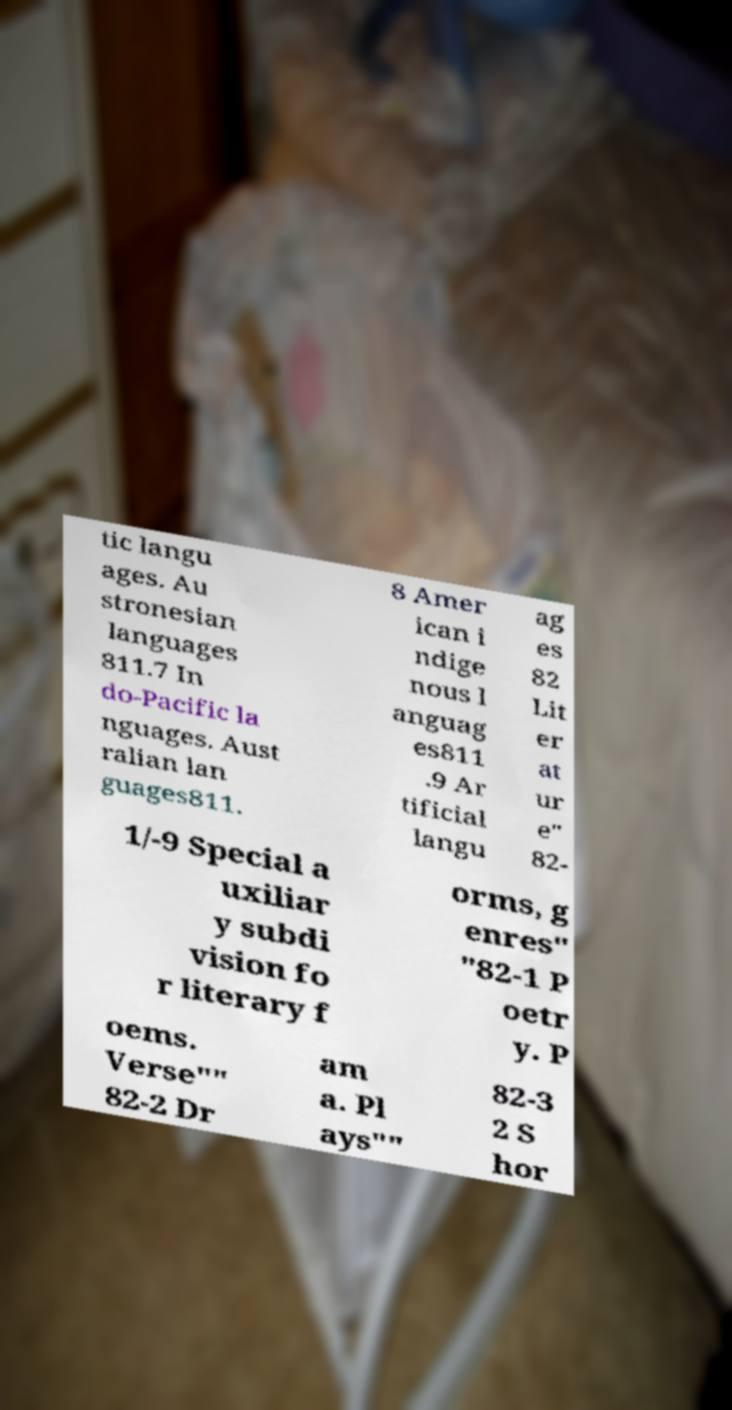There's text embedded in this image that I need extracted. Can you transcribe it verbatim? tic langu ages. Au stronesian languages 811.7 In do-Pacific la nguages. Aust ralian lan guages811. 8 Amer ican i ndige nous l anguag es811 .9 Ar tificial langu ag es 82 Lit er at ur e" 82- 1/-9 Special a uxiliar y subdi vision fo r literary f orms, g enres" "82-1 P oetr y. P oems. Verse"" 82-2 Dr am a. Pl ays"" 82-3 2 S hor 